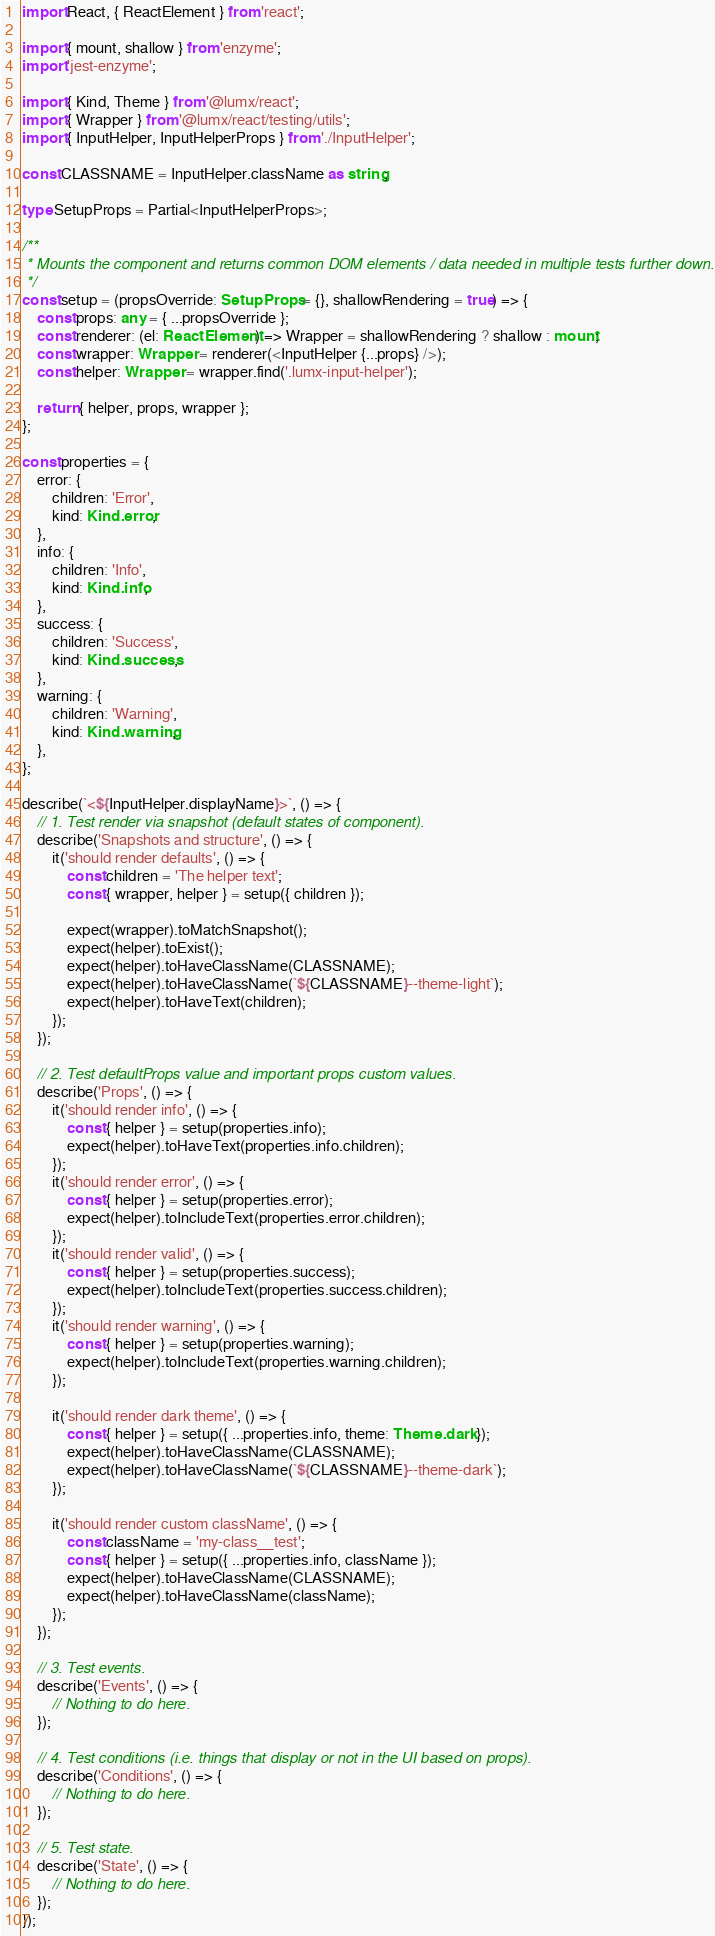<code> <loc_0><loc_0><loc_500><loc_500><_TypeScript_>import React, { ReactElement } from 'react';

import { mount, shallow } from 'enzyme';
import 'jest-enzyme';

import { Kind, Theme } from '@lumx/react';
import { Wrapper } from '@lumx/react/testing/utils';
import { InputHelper, InputHelperProps } from './InputHelper';

const CLASSNAME = InputHelper.className as string;

type SetupProps = Partial<InputHelperProps>;

/**
 * Mounts the component and returns common DOM elements / data needed in multiple tests further down.
 */
const setup = (propsOverride: SetupProps = {}, shallowRendering = true) => {
    const props: any = { ...propsOverride };
    const renderer: (el: ReactElement) => Wrapper = shallowRendering ? shallow : mount;
    const wrapper: Wrapper = renderer(<InputHelper {...props} />);
    const helper: Wrapper = wrapper.find('.lumx-input-helper');

    return { helper, props, wrapper };
};

const properties = {
    error: {
        children: 'Error',
        kind: Kind.error,
    },
    info: {
        children: 'Info',
        kind: Kind.info,
    },
    success: {
        children: 'Success',
        kind: Kind.success,
    },
    warning: {
        children: 'Warning',
        kind: Kind.warning,
    },
};

describe(`<${InputHelper.displayName}>`, () => {
    // 1. Test render via snapshot (default states of component).
    describe('Snapshots and structure', () => {
        it('should render defaults', () => {
            const children = 'The helper text';
            const { wrapper, helper } = setup({ children });

            expect(wrapper).toMatchSnapshot();
            expect(helper).toExist();
            expect(helper).toHaveClassName(CLASSNAME);
            expect(helper).toHaveClassName(`${CLASSNAME}--theme-light`);
            expect(helper).toHaveText(children);
        });
    });

    // 2. Test defaultProps value and important props custom values.
    describe('Props', () => {
        it('should render info', () => {
            const { helper } = setup(properties.info);
            expect(helper).toHaveText(properties.info.children);
        });
        it('should render error', () => {
            const { helper } = setup(properties.error);
            expect(helper).toIncludeText(properties.error.children);
        });
        it('should render valid', () => {
            const { helper } = setup(properties.success);
            expect(helper).toIncludeText(properties.success.children);
        });
        it('should render warning', () => {
            const { helper } = setup(properties.warning);
            expect(helper).toIncludeText(properties.warning.children);
        });

        it('should render dark theme', () => {
            const { helper } = setup({ ...properties.info, theme: Theme.dark });
            expect(helper).toHaveClassName(CLASSNAME);
            expect(helper).toHaveClassName(`${CLASSNAME}--theme-dark`);
        });

        it('should render custom className', () => {
            const className = 'my-class__test';
            const { helper } = setup({ ...properties.info, className });
            expect(helper).toHaveClassName(CLASSNAME);
            expect(helper).toHaveClassName(className);
        });
    });

    // 3. Test events.
    describe('Events', () => {
        // Nothing to do here.
    });

    // 4. Test conditions (i.e. things that display or not in the UI based on props).
    describe('Conditions', () => {
        // Nothing to do here.
    });

    // 5. Test state.
    describe('State', () => {
        // Nothing to do here.
    });
});
</code> 